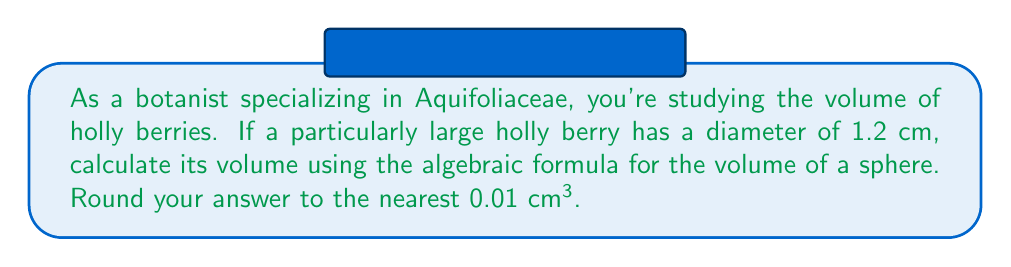Teach me how to tackle this problem. To solve this problem, we'll follow these steps:

1. Recall the formula for the volume of a sphere:
   $$V = \frac{4}{3}\pi r^3$$
   where $V$ is the volume and $r$ is the radius.

2. We're given the diameter, so we need to find the radius:
   $$r = \frac{\text{diameter}}{2} = \frac{1.2 \text{ cm}}{2} = 0.6 \text{ cm}$$

3. Now, let's substitute this into our volume formula:
   $$V = \frac{4}{3}\pi (0.6 \text{ cm})^3$$

4. Simplify the calculation:
   $$V = \frac{4}{3}\pi (0.216 \text{ cm}^3)$$
   $$V \approx 4.1887902 \text{ cm}^3$$

5. Rounding to the nearest 0.01 cm³:
   $$V \approx 4.19 \text{ cm}^3$$
Answer: $4.19 \text{ cm}^3$ 